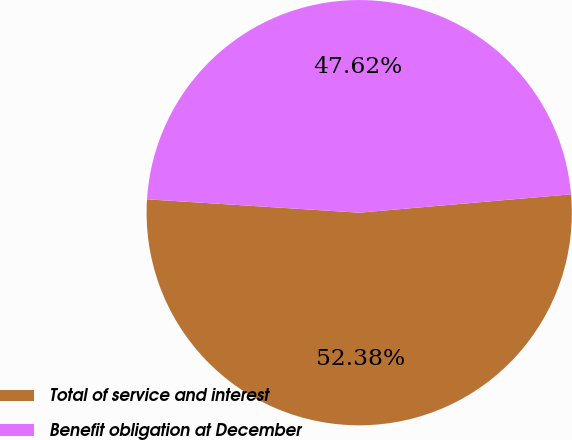Convert chart to OTSL. <chart><loc_0><loc_0><loc_500><loc_500><pie_chart><fcel>Total of service and interest<fcel>Benefit obligation at December<nl><fcel>52.38%<fcel>47.62%<nl></chart> 